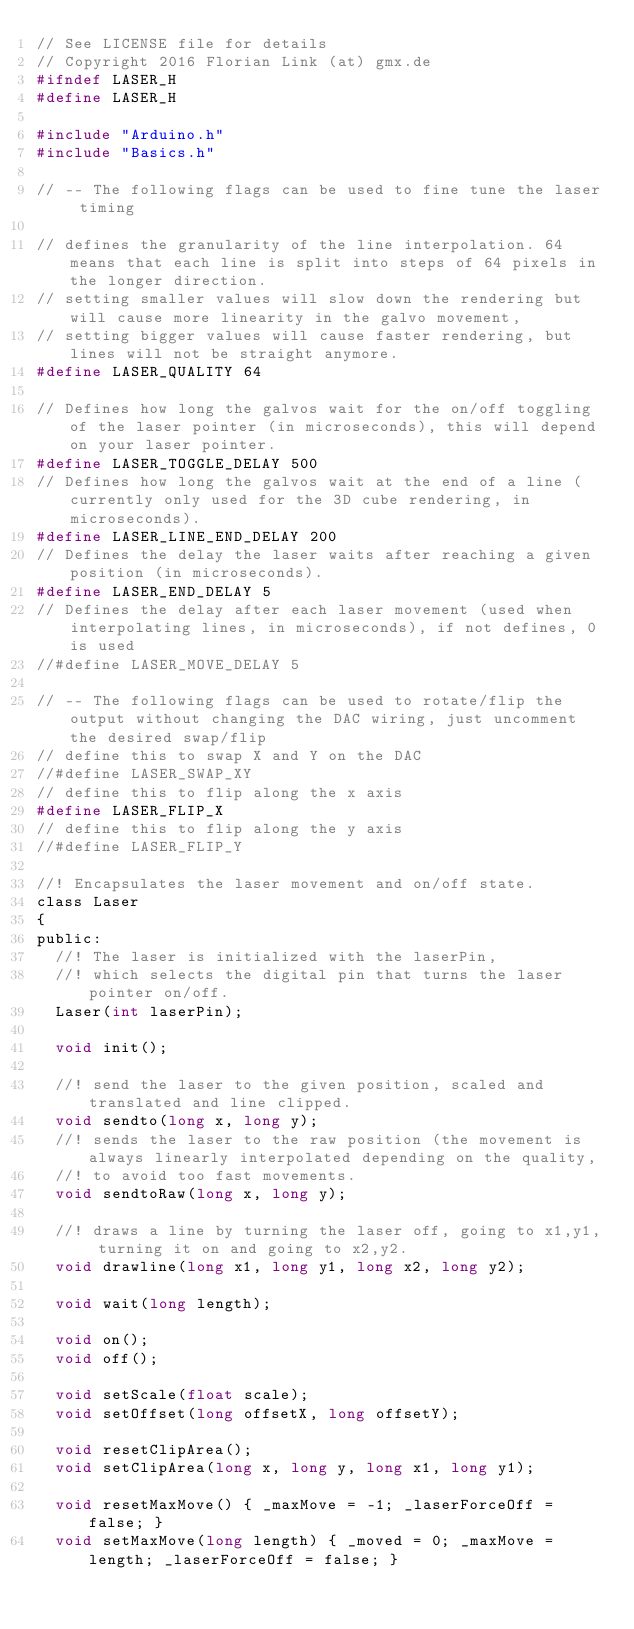<code> <loc_0><loc_0><loc_500><loc_500><_C_>// See LICENSE file for details
// Copyright 2016 Florian Link (at) gmx.de
#ifndef LASER_H
#define LASER_H

#include "Arduino.h"
#include "Basics.h"

// -- The following flags can be used to fine tune the laser timing

// defines the granularity of the line interpolation. 64 means that each line is split into steps of 64 pixels in the longer direction.
// setting smaller values will slow down the rendering but will cause more linearity in the galvo movement,
// setting bigger values will cause faster rendering, but lines will not be straight anymore.
#define LASER_QUALITY 64

// Defines how long the galvos wait for the on/off toggling of the laser pointer (in microseconds), this will depend on your laser pointer.
#define LASER_TOGGLE_DELAY 500
// Defines how long the galvos wait at the end of a line (currently only used for the 3D cube rendering, in microseconds).
#define LASER_LINE_END_DELAY 200
// Defines the delay the laser waits after reaching a given position (in microseconds).
#define LASER_END_DELAY 5
// Defines the delay after each laser movement (used when interpolating lines, in microseconds), if not defines, 0 is used
//#define LASER_MOVE_DELAY 5

// -- The following flags can be used to rotate/flip the output without changing the DAC wiring, just uncomment the desired swap/flip
// define this to swap X and Y on the DAC
//#define LASER_SWAP_XY
// define this to flip along the x axis
#define LASER_FLIP_X
// define this to flip along the y axis
//#define LASER_FLIP_Y

//! Encapsulates the laser movement and on/off state.
class Laser
{
public:
  //! The laser is initialized with the laserPin,
  //! which selects the digital pin that turns the laser pointer on/off.
  Laser(int laserPin);

  void init();

  //! send the laser to the given position, scaled and translated and line clipped.
  void sendto(long x, long y);
  //! sends the laser to the raw position (the movement is always linearly interpolated depending on the quality,
  //! to avoid too fast movements.
  void sendtoRaw(long x, long y);

  //! draws a line by turning the laser off, going to x1,y1, turning it on and going to x2,y2.
  void drawline(long x1, long y1, long x2, long y2);

  void wait(long length);

  void on();
  void off();
  
  void setScale(float scale);
  void setOffset(long offsetX, long offsetY);
  
  void resetClipArea(); 
  void setClipArea(long x, long y, long x1, long y1);

  void resetMaxMove() { _maxMove = -1; _laserForceOff = false; }
  void setMaxMove(long length) { _moved = 0; _maxMove = length; _laserForceOff = false; }</code> 